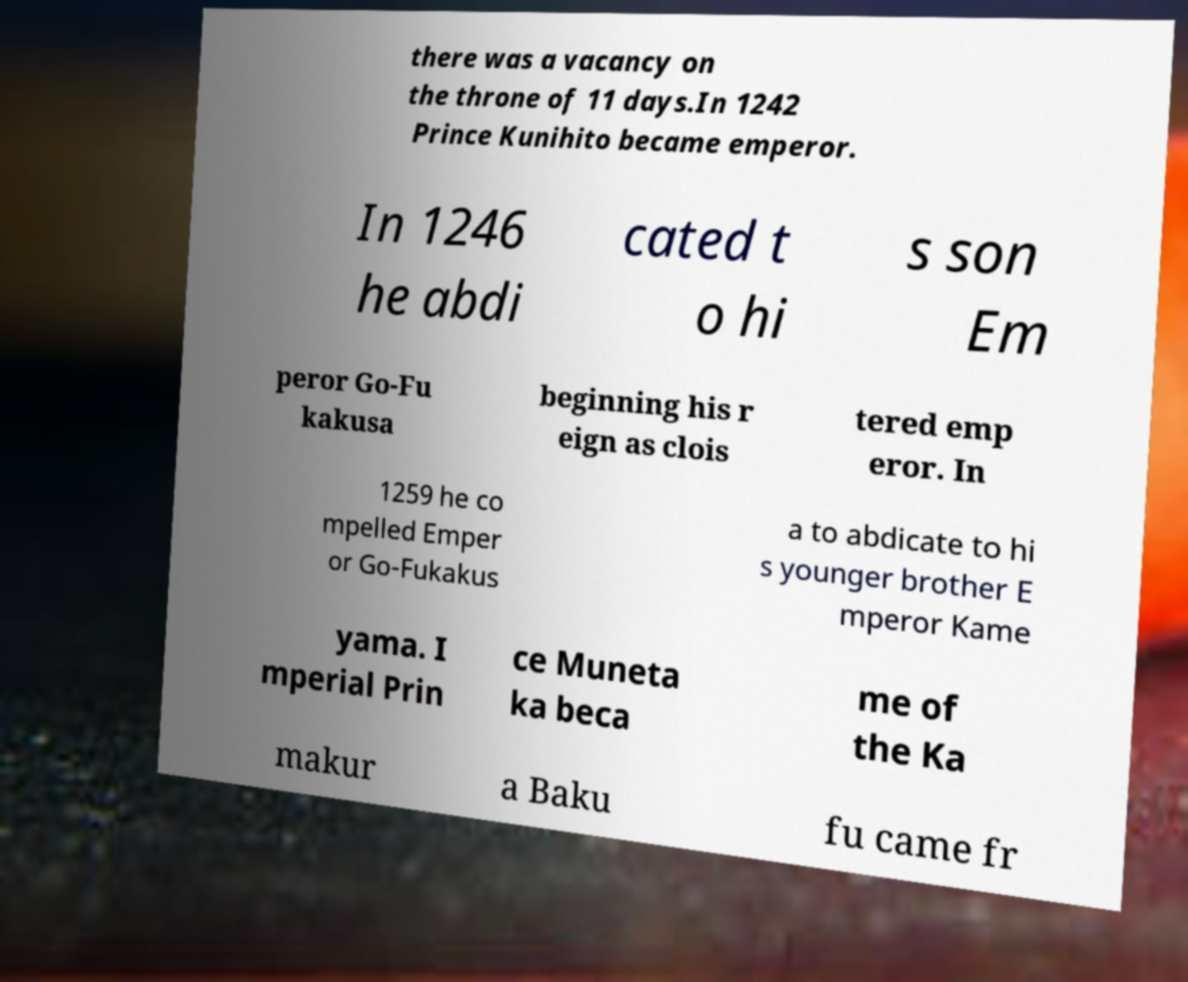Can you accurately transcribe the text from the provided image for me? there was a vacancy on the throne of 11 days.In 1242 Prince Kunihito became emperor. In 1246 he abdi cated t o hi s son Em peror Go-Fu kakusa beginning his r eign as clois tered emp eror. In 1259 he co mpelled Emper or Go-Fukakus a to abdicate to hi s younger brother E mperor Kame yama. I mperial Prin ce Muneta ka beca me of the Ka makur a Baku fu came fr 